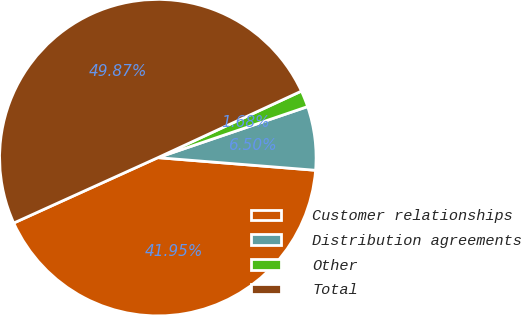Convert chart. <chart><loc_0><loc_0><loc_500><loc_500><pie_chart><fcel>Customer relationships<fcel>Distribution agreements<fcel>Other<fcel>Total<nl><fcel>41.95%<fcel>6.5%<fcel>1.68%<fcel>49.87%<nl></chart> 